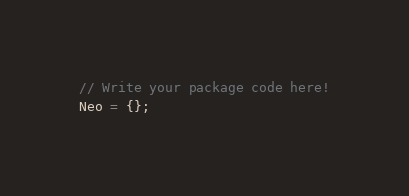<code> <loc_0><loc_0><loc_500><loc_500><_JavaScript_>// Write your package code here!
Neo = {};</code> 